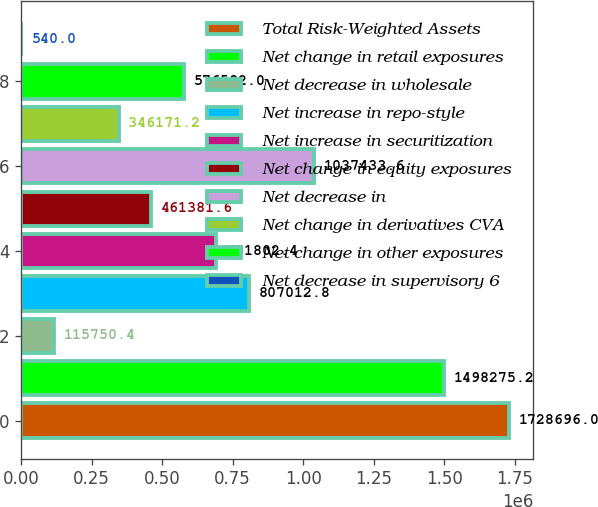Convert chart. <chart><loc_0><loc_0><loc_500><loc_500><bar_chart><fcel>Total Risk-Weighted Assets<fcel>Net change in retail exposures<fcel>Net decrease in wholesale<fcel>Net increase in repo-style<fcel>Net increase in securitization<fcel>Net change in equity exposures<fcel>Net decrease in<fcel>Net change in derivatives CVA<fcel>Net change in other exposures<fcel>Net decrease in supervisory 6<nl><fcel>1.7287e+06<fcel>1.49828e+06<fcel>115750<fcel>807013<fcel>691802<fcel>461382<fcel>1.03743e+06<fcel>346171<fcel>576592<fcel>540<nl></chart> 